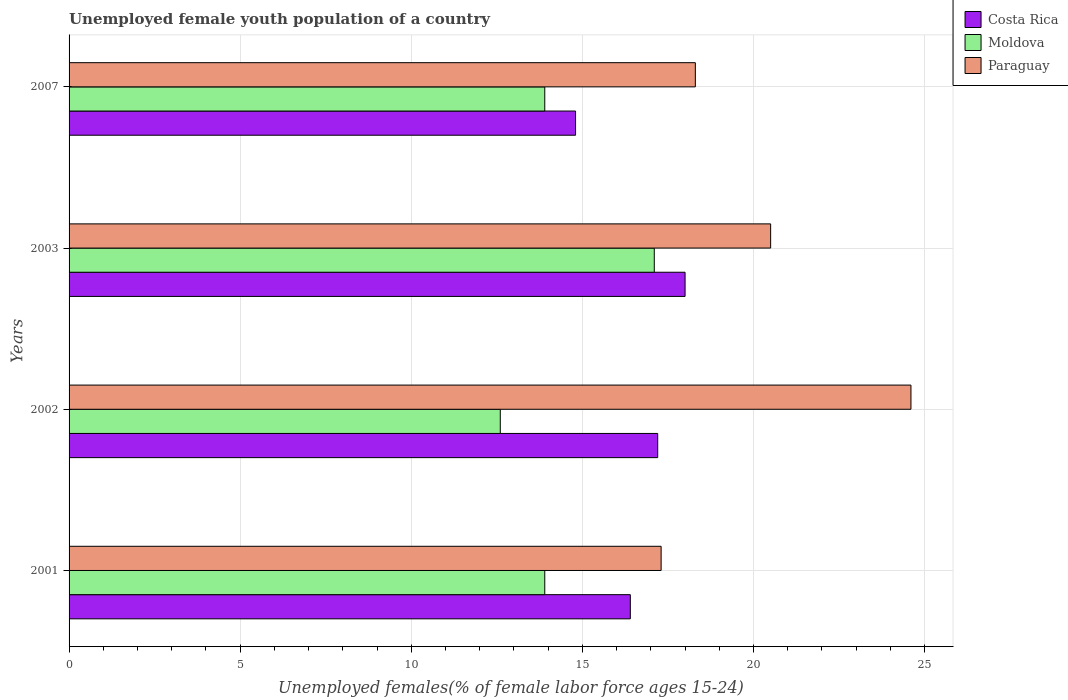How many groups of bars are there?
Provide a short and direct response. 4. Are the number of bars on each tick of the Y-axis equal?
Your response must be concise. Yes. How many bars are there on the 4th tick from the top?
Make the answer very short. 3. How many bars are there on the 2nd tick from the bottom?
Provide a succinct answer. 3. What is the label of the 1st group of bars from the top?
Keep it short and to the point. 2007. In how many cases, is the number of bars for a given year not equal to the number of legend labels?
Provide a short and direct response. 0. What is the percentage of unemployed female youth population in Paraguay in 2002?
Your response must be concise. 24.6. Across all years, what is the maximum percentage of unemployed female youth population in Moldova?
Your response must be concise. 17.1. Across all years, what is the minimum percentage of unemployed female youth population in Moldova?
Keep it short and to the point. 12.6. What is the total percentage of unemployed female youth population in Moldova in the graph?
Your answer should be compact. 57.5. What is the difference between the percentage of unemployed female youth population in Paraguay in 2001 and that in 2003?
Your response must be concise. -3.2. What is the difference between the percentage of unemployed female youth population in Paraguay in 2007 and the percentage of unemployed female youth population in Costa Rica in 2001?
Provide a short and direct response. 1.9. What is the average percentage of unemployed female youth population in Moldova per year?
Provide a short and direct response. 14.38. In the year 2003, what is the difference between the percentage of unemployed female youth population in Moldova and percentage of unemployed female youth population in Paraguay?
Provide a short and direct response. -3.4. What is the ratio of the percentage of unemployed female youth population in Costa Rica in 2002 to that in 2007?
Provide a succinct answer. 1.16. What is the difference between the highest and the second highest percentage of unemployed female youth population in Costa Rica?
Your answer should be compact. 0.8. What is the difference between the highest and the lowest percentage of unemployed female youth population in Moldova?
Make the answer very short. 4.5. In how many years, is the percentage of unemployed female youth population in Costa Rica greater than the average percentage of unemployed female youth population in Costa Rica taken over all years?
Provide a succinct answer. 2. What does the 1st bar from the top in 2003 represents?
Give a very brief answer. Paraguay. What does the 1st bar from the bottom in 2002 represents?
Give a very brief answer. Costa Rica. Are all the bars in the graph horizontal?
Your answer should be compact. Yes. Does the graph contain grids?
Your response must be concise. Yes. How many legend labels are there?
Give a very brief answer. 3. How are the legend labels stacked?
Keep it short and to the point. Vertical. What is the title of the graph?
Provide a short and direct response. Unemployed female youth population of a country. Does "Haiti" appear as one of the legend labels in the graph?
Your answer should be very brief. No. What is the label or title of the X-axis?
Your answer should be compact. Unemployed females(% of female labor force ages 15-24). What is the label or title of the Y-axis?
Your answer should be compact. Years. What is the Unemployed females(% of female labor force ages 15-24) of Costa Rica in 2001?
Your response must be concise. 16.4. What is the Unemployed females(% of female labor force ages 15-24) of Moldova in 2001?
Keep it short and to the point. 13.9. What is the Unemployed females(% of female labor force ages 15-24) in Paraguay in 2001?
Make the answer very short. 17.3. What is the Unemployed females(% of female labor force ages 15-24) of Costa Rica in 2002?
Provide a succinct answer. 17.2. What is the Unemployed females(% of female labor force ages 15-24) in Moldova in 2002?
Your answer should be compact. 12.6. What is the Unemployed females(% of female labor force ages 15-24) in Paraguay in 2002?
Make the answer very short. 24.6. What is the Unemployed females(% of female labor force ages 15-24) in Costa Rica in 2003?
Give a very brief answer. 18. What is the Unemployed females(% of female labor force ages 15-24) of Moldova in 2003?
Your response must be concise. 17.1. What is the Unemployed females(% of female labor force ages 15-24) of Costa Rica in 2007?
Give a very brief answer. 14.8. What is the Unemployed females(% of female labor force ages 15-24) in Moldova in 2007?
Offer a very short reply. 13.9. What is the Unemployed females(% of female labor force ages 15-24) of Paraguay in 2007?
Offer a very short reply. 18.3. Across all years, what is the maximum Unemployed females(% of female labor force ages 15-24) in Moldova?
Ensure brevity in your answer.  17.1. Across all years, what is the maximum Unemployed females(% of female labor force ages 15-24) of Paraguay?
Ensure brevity in your answer.  24.6. Across all years, what is the minimum Unemployed females(% of female labor force ages 15-24) in Costa Rica?
Make the answer very short. 14.8. Across all years, what is the minimum Unemployed females(% of female labor force ages 15-24) in Moldova?
Your response must be concise. 12.6. Across all years, what is the minimum Unemployed females(% of female labor force ages 15-24) of Paraguay?
Make the answer very short. 17.3. What is the total Unemployed females(% of female labor force ages 15-24) of Costa Rica in the graph?
Ensure brevity in your answer.  66.4. What is the total Unemployed females(% of female labor force ages 15-24) of Moldova in the graph?
Your response must be concise. 57.5. What is the total Unemployed females(% of female labor force ages 15-24) of Paraguay in the graph?
Provide a succinct answer. 80.7. What is the difference between the Unemployed females(% of female labor force ages 15-24) of Moldova in 2001 and that in 2003?
Provide a succinct answer. -3.2. What is the difference between the Unemployed females(% of female labor force ages 15-24) of Costa Rica in 2001 and that in 2007?
Offer a very short reply. 1.6. What is the difference between the Unemployed females(% of female labor force ages 15-24) of Moldova in 2001 and that in 2007?
Your answer should be very brief. 0. What is the difference between the Unemployed females(% of female labor force ages 15-24) of Costa Rica in 2002 and that in 2003?
Give a very brief answer. -0.8. What is the difference between the Unemployed females(% of female labor force ages 15-24) of Costa Rica in 2002 and that in 2007?
Your answer should be compact. 2.4. What is the difference between the Unemployed females(% of female labor force ages 15-24) of Moldova in 2002 and that in 2007?
Make the answer very short. -1.3. What is the difference between the Unemployed females(% of female labor force ages 15-24) of Moldova in 2003 and that in 2007?
Your response must be concise. 3.2. What is the difference between the Unemployed females(% of female labor force ages 15-24) in Costa Rica in 2001 and the Unemployed females(% of female labor force ages 15-24) in Moldova in 2002?
Provide a succinct answer. 3.8. What is the difference between the Unemployed females(% of female labor force ages 15-24) of Costa Rica in 2001 and the Unemployed females(% of female labor force ages 15-24) of Paraguay in 2002?
Give a very brief answer. -8.2. What is the difference between the Unemployed females(% of female labor force ages 15-24) in Costa Rica in 2001 and the Unemployed females(% of female labor force ages 15-24) in Paraguay in 2003?
Provide a succinct answer. -4.1. What is the difference between the Unemployed females(% of female labor force ages 15-24) in Moldova in 2001 and the Unemployed females(% of female labor force ages 15-24) in Paraguay in 2003?
Offer a very short reply. -6.6. What is the difference between the Unemployed females(% of female labor force ages 15-24) in Costa Rica in 2001 and the Unemployed females(% of female labor force ages 15-24) in Moldova in 2007?
Offer a terse response. 2.5. What is the difference between the Unemployed females(% of female labor force ages 15-24) in Moldova in 2001 and the Unemployed females(% of female labor force ages 15-24) in Paraguay in 2007?
Provide a succinct answer. -4.4. What is the difference between the Unemployed females(% of female labor force ages 15-24) in Costa Rica in 2002 and the Unemployed females(% of female labor force ages 15-24) in Moldova in 2003?
Keep it short and to the point. 0.1. What is the difference between the Unemployed females(% of female labor force ages 15-24) in Costa Rica in 2002 and the Unemployed females(% of female labor force ages 15-24) in Moldova in 2007?
Provide a short and direct response. 3.3. What is the difference between the Unemployed females(% of female labor force ages 15-24) of Moldova in 2002 and the Unemployed females(% of female labor force ages 15-24) of Paraguay in 2007?
Offer a terse response. -5.7. What is the difference between the Unemployed females(% of female labor force ages 15-24) of Costa Rica in 2003 and the Unemployed females(% of female labor force ages 15-24) of Moldova in 2007?
Your answer should be compact. 4.1. What is the difference between the Unemployed females(% of female labor force ages 15-24) of Costa Rica in 2003 and the Unemployed females(% of female labor force ages 15-24) of Paraguay in 2007?
Your answer should be compact. -0.3. What is the difference between the Unemployed females(% of female labor force ages 15-24) of Moldova in 2003 and the Unemployed females(% of female labor force ages 15-24) of Paraguay in 2007?
Offer a very short reply. -1.2. What is the average Unemployed females(% of female labor force ages 15-24) in Moldova per year?
Offer a terse response. 14.38. What is the average Unemployed females(% of female labor force ages 15-24) in Paraguay per year?
Provide a short and direct response. 20.18. In the year 2001, what is the difference between the Unemployed females(% of female labor force ages 15-24) of Costa Rica and Unemployed females(% of female labor force ages 15-24) of Paraguay?
Provide a short and direct response. -0.9. In the year 2001, what is the difference between the Unemployed females(% of female labor force ages 15-24) in Moldova and Unemployed females(% of female labor force ages 15-24) in Paraguay?
Your response must be concise. -3.4. In the year 2003, what is the difference between the Unemployed females(% of female labor force ages 15-24) of Costa Rica and Unemployed females(% of female labor force ages 15-24) of Moldova?
Your response must be concise. 0.9. In the year 2003, what is the difference between the Unemployed females(% of female labor force ages 15-24) of Costa Rica and Unemployed females(% of female labor force ages 15-24) of Paraguay?
Provide a succinct answer. -2.5. In the year 2007, what is the difference between the Unemployed females(% of female labor force ages 15-24) of Costa Rica and Unemployed females(% of female labor force ages 15-24) of Moldova?
Your response must be concise. 0.9. What is the ratio of the Unemployed females(% of female labor force ages 15-24) of Costa Rica in 2001 to that in 2002?
Provide a succinct answer. 0.95. What is the ratio of the Unemployed females(% of female labor force ages 15-24) of Moldova in 2001 to that in 2002?
Offer a very short reply. 1.1. What is the ratio of the Unemployed females(% of female labor force ages 15-24) of Paraguay in 2001 to that in 2002?
Provide a succinct answer. 0.7. What is the ratio of the Unemployed females(% of female labor force ages 15-24) in Costa Rica in 2001 to that in 2003?
Your answer should be compact. 0.91. What is the ratio of the Unemployed females(% of female labor force ages 15-24) in Moldova in 2001 to that in 2003?
Ensure brevity in your answer.  0.81. What is the ratio of the Unemployed females(% of female labor force ages 15-24) in Paraguay in 2001 to that in 2003?
Your answer should be very brief. 0.84. What is the ratio of the Unemployed females(% of female labor force ages 15-24) of Costa Rica in 2001 to that in 2007?
Your answer should be compact. 1.11. What is the ratio of the Unemployed females(% of female labor force ages 15-24) of Paraguay in 2001 to that in 2007?
Keep it short and to the point. 0.95. What is the ratio of the Unemployed females(% of female labor force ages 15-24) in Costa Rica in 2002 to that in 2003?
Ensure brevity in your answer.  0.96. What is the ratio of the Unemployed females(% of female labor force ages 15-24) of Moldova in 2002 to that in 2003?
Offer a very short reply. 0.74. What is the ratio of the Unemployed females(% of female labor force ages 15-24) of Costa Rica in 2002 to that in 2007?
Your answer should be compact. 1.16. What is the ratio of the Unemployed females(% of female labor force ages 15-24) of Moldova in 2002 to that in 2007?
Offer a very short reply. 0.91. What is the ratio of the Unemployed females(% of female labor force ages 15-24) of Paraguay in 2002 to that in 2007?
Provide a succinct answer. 1.34. What is the ratio of the Unemployed females(% of female labor force ages 15-24) in Costa Rica in 2003 to that in 2007?
Keep it short and to the point. 1.22. What is the ratio of the Unemployed females(% of female labor force ages 15-24) of Moldova in 2003 to that in 2007?
Offer a very short reply. 1.23. What is the ratio of the Unemployed females(% of female labor force ages 15-24) in Paraguay in 2003 to that in 2007?
Ensure brevity in your answer.  1.12. What is the difference between the highest and the second highest Unemployed females(% of female labor force ages 15-24) of Moldova?
Provide a short and direct response. 3.2. What is the difference between the highest and the lowest Unemployed females(% of female labor force ages 15-24) in Costa Rica?
Provide a succinct answer. 3.2. What is the difference between the highest and the lowest Unemployed females(% of female labor force ages 15-24) of Moldova?
Offer a very short reply. 4.5. What is the difference between the highest and the lowest Unemployed females(% of female labor force ages 15-24) of Paraguay?
Make the answer very short. 7.3. 